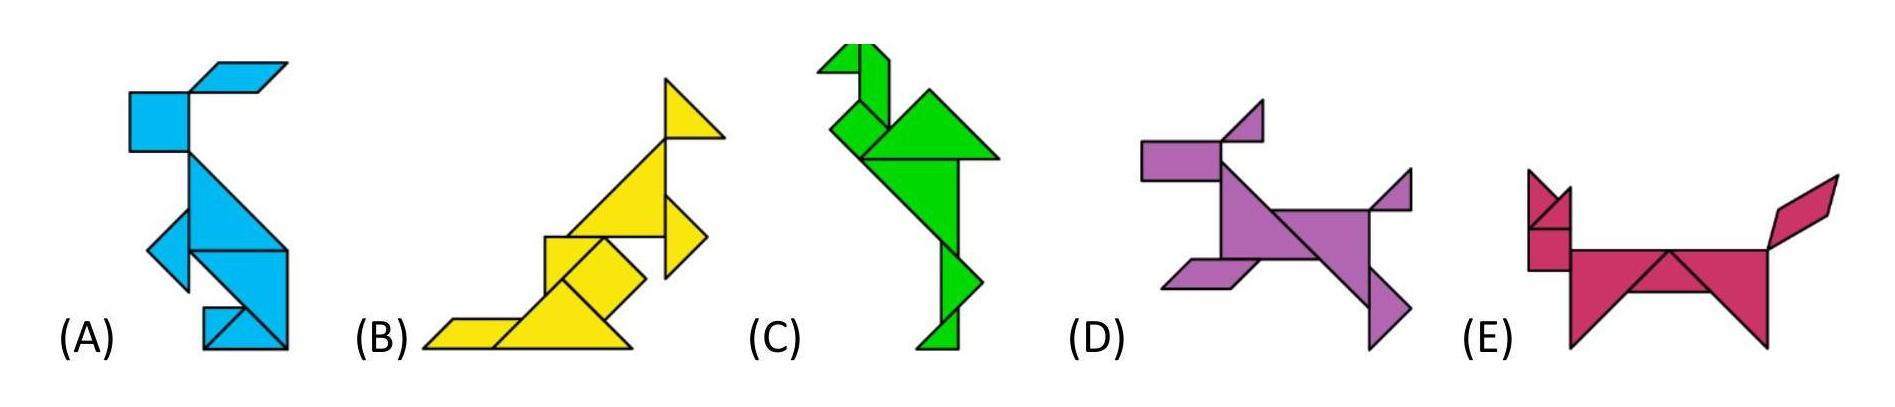Can you describe the differences between animals A and B? Animal A is composed of a series of blue parallelograms, arranged to depict what seems to be a kangaroo or a similar hopping animal, with a prominent tail and angled legs poised for movement. Animal B, on the other hand, takes the form of a yellow creature that might be likened to a bird, bearing elongated triangular shapes to form its beak and wing, set in a stance that suggests flight or landing. 